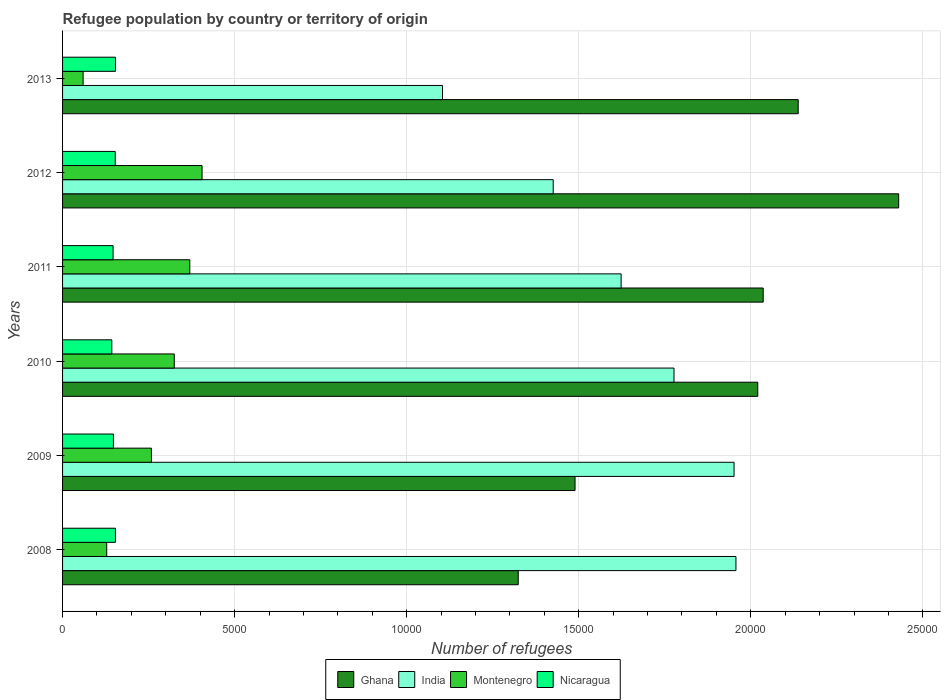How many groups of bars are there?
Offer a terse response. 6. Are the number of bars per tick equal to the number of legend labels?
Your answer should be very brief. Yes. How many bars are there on the 2nd tick from the bottom?
Make the answer very short. 4. In how many cases, is the number of bars for a given year not equal to the number of legend labels?
Offer a very short reply. 0. What is the number of refugees in Montenegro in 2008?
Keep it short and to the point. 1283. Across all years, what is the maximum number of refugees in Montenegro?
Provide a succinct answer. 4054. Across all years, what is the minimum number of refugees in Nicaragua?
Your response must be concise. 1431. In which year was the number of refugees in Montenegro maximum?
Provide a short and direct response. 2012. In which year was the number of refugees in Ghana minimum?
Ensure brevity in your answer.  2008. What is the total number of refugees in Ghana in the graph?
Offer a very short reply. 1.14e+05. What is the difference between the number of refugees in India in 2010 and that in 2011?
Keep it short and to the point. 1537. What is the difference between the number of refugees in Ghana in 2009 and the number of refugees in Nicaragua in 2012?
Offer a very short reply. 1.34e+04. What is the average number of refugees in Nicaragua per year?
Offer a very short reply. 1497.17. In the year 2009, what is the difference between the number of refugees in Ghana and number of refugees in Nicaragua?
Make the answer very short. 1.34e+04. In how many years, is the number of refugees in Ghana greater than 3000 ?
Your answer should be very brief. 6. What is the ratio of the number of refugees in Montenegro in 2012 to that in 2013?
Give a very brief answer. 6.79. What is the difference between the highest and the lowest number of refugees in Ghana?
Offer a terse response. 1.11e+04. In how many years, is the number of refugees in Montenegro greater than the average number of refugees in Montenegro taken over all years?
Provide a short and direct response. 4. Is it the case that in every year, the sum of the number of refugees in Nicaragua and number of refugees in Ghana is greater than the sum of number of refugees in India and number of refugees in Montenegro?
Your answer should be compact. Yes. What does the 2nd bar from the top in 2012 represents?
Your answer should be compact. Montenegro. What does the 4th bar from the bottom in 2011 represents?
Give a very brief answer. Nicaragua. How many years are there in the graph?
Ensure brevity in your answer.  6. What is the difference between two consecutive major ticks on the X-axis?
Offer a very short reply. 5000. Are the values on the major ticks of X-axis written in scientific E-notation?
Your response must be concise. No. Does the graph contain any zero values?
Offer a very short reply. No. How are the legend labels stacked?
Give a very brief answer. Horizontal. What is the title of the graph?
Your answer should be compact. Refugee population by country or territory of origin. Does "Cambodia" appear as one of the legend labels in the graph?
Offer a terse response. No. What is the label or title of the X-axis?
Provide a succinct answer. Number of refugees. What is the Number of refugees in Ghana in 2008?
Ensure brevity in your answer.  1.32e+04. What is the Number of refugees in India in 2008?
Ensure brevity in your answer.  1.96e+04. What is the Number of refugees in Montenegro in 2008?
Provide a short and direct response. 1283. What is the Number of refugees in Nicaragua in 2008?
Give a very brief answer. 1537. What is the Number of refugees in Ghana in 2009?
Offer a very short reply. 1.49e+04. What is the Number of refugees in India in 2009?
Make the answer very short. 1.95e+04. What is the Number of refugees of Montenegro in 2009?
Your answer should be very brief. 2582. What is the Number of refugees in Nicaragua in 2009?
Provide a succinct answer. 1478. What is the Number of refugees of Ghana in 2010?
Provide a short and direct response. 2.02e+04. What is the Number of refugees of India in 2010?
Ensure brevity in your answer.  1.78e+04. What is the Number of refugees of Montenegro in 2010?
Provide a succinct answer. 3246. What is the Number of refugees in Nicaragua in 2010?
Provide a succinct answer. 1431. What is the Number of refugees in Ghana in 2011?
Offer a terse response. 2.04e+04. What is the Number of refugees of India in 2011?
Your answer should be compact. 1.62e+04. What is the Number of refugees in Montenegro in 2011?
Provide a succinct answer. 3698. What is the Number of refugees in Nicaragua in 2011?
Offer a terse response. 1468. What is the Number of refugees in Ghana in 2012?
Offer a very short reply. 2.43e+04. What is the Number of refugees in India in 2012?
Provide a succinct answer. 1.43e+04. What is the Number of refugees of Montenegro in 2012?
Ensure brevity in your answer.  4054. What is the Number of refugees of Nicaragua in 2012?
Provide a short and direct response. 1531. What is the Number of refugees in Ghana in 2013?
Ensure brevity in your answer.  2.14e+04. What is the Number of refugees in India in 2013?
Give a very brief answer. 1.10e+04. What is the Number of refugees of Montenegro in 2013?
Provide a short and direct response. 597. What is the Number of refugees of Nicaragua in 2013?
Make the answer very short. 1538. Across all years, what is the maximum Number of refugees of Ghana?
Your answer should be compact. 2.43e+04. Across all years, what is the maximum Number of refugees in India?
Your answer should be compact. 1.96e+04. Across all years, what is the maximum Number of refugees of Montenegro?
Your answer should be very brief. 4054. Across all years, what is the maximum Number of refugees of Nicaragua?
Provide a short and direct response. 1538. Across all years, what is the minimum Number of refugees of Ghana?
Keep it short and to the point. 1.32e+04. Across all years, what is the minimum Number of refugees in India?
Your answer should be very brief. 1.10e+04. Across all years, what is the minimum Number of refugees of Montenegro?
Your answer should be very brief. 597. Across all years, what is the minimum Number of refugees in Nicaragua?
Provide a succinct answer. 1431. What is the total Number of refugees in Ghana in the graph?
Ensure brevity in your answer.  1.14e+05. What is the total Number of refugees in India in the graph?
Keep it short and to the point. 9.84e+04. What is the total Number of refugees of Montenegro in the graph?
Your response must be concise. 1.55e+04. What is the total Number of refugees of Nicaragua in the graph?
Keep it short and to the point. 8983. What is the difference between the Number of refugees of Ghana in 2008 and that in 2009?
Provide a short and direct response. -1651. What is the difference between the Number of refugees in India in 2008 and that in 2009?
Ensure brevity in your answer.  55. What is the difference between the Number of refugees of Montenegro in 2008 and that in 2009?
Provide a short and direct response. -1299. What is the difference between the Number of refugees of Ghana in 2008 and that in 2010?
Keep it short and to the point. -6961. What is the difference between the Number of refugees in India in 2008 and that in 2010?
Provide a short and direct response. 1800. What is the difference between the Number of refugees in Montenegro in 2008 and that in 2010?
Your answer should be compact. -1963. What is the difference between the Number of refugees in Nicaragua in 2008 and that in 2010?
Make the answer very short. 106. What is the difference between the Number of refugees in Ghana in 2008 and that in 2011?
Provide a short and direct response. -7119. What is the difference between the Number of refugees in India in 2008 and that in 2011?
Give a very brief answer. 3337. What is the difference between the Number of refugees in Montenegro in 2008 and that in 2011?
Your answer should be very brief. -2415. What is the difference between the Number of refugees in Nicaragua in 2008 and that in 2011?
Your answer should be compact. 69. What is the difference between the Number of refugees in Ghana in 2008 and that in 2012?
Ensure brevity in your answer.  -1.11e+04. What is the difference between the Number of refugees in India in 2008 and that in 2012?
Give a very brief answer. 5311. What is the difference between the Number of refugees in Montenegro in 2008 and that in 2012?
Ensure brevity in your answer.  -2771. What is the difference between the Number of refugees of Ghana in 2008 and that in 2013?
Your answer should be compact. -8136. What is the difference between the Number of refugees of India in 2008 and that in 2013?
Ensure brevity in your answer.  8527. What is the difference between the Number of refugees of Montenegro in 2008 and that in 2013?
Your response must be concise. 686. What is the difference between the Number of refugees of Ghana in 2009 and that in 2010?
Keep it short and to the point. -5310. What is the difference between the Number of refugees of India in 2009 and that in 2010?
Your answer should be compact. 1745. What is the difference between the Number of refugees in Montenegro in 2009 and that in 2010?
Offer a very short reply. -664. What is the difference between the Number of refugees in Nicaragua in 2009 and that in 2010?
Offer a terse response. 47. What is the difference between the Number of refugees in Ghana in 2009 and that in 2011?
Provide a short and direct response. -5468. What is the difference between the Number of refugees of India in 2009 and that in 2011?
Keep it short and to the point. 3282. What is the difference between the Number of refugees in Montenegro in 2009 and that in 2011?
Make the answer very short. -1116. What is the difference between the Number of refugees of Ghana in 2009 and that in 2012?
Offer a terse response. -9405. What is the difference between the Number of refugees in India in 2009 and that in 2012?
Your answer should be very brief. 5256. What is the difference between the Number of refugees of Montenegro in 2009 and that in 2012?
Provide a short and direct response. -1472. What is the difference between the Number of refugees of Nicaragua in 2009 and that in 2012?
Make the answer very short. -53. What is the difference between the Number of refugees in Ghana in 2009 and that in 2013?
Offer a very short reply. -6485. What is the difference between the Number of refugees in India in 2009 and that in 2013?
Your answer should be very brief. 8472. What is the difference between the Number of refugees in Montenegro in 2009 and that in 2013?
Your answer should be compact. 1985. What is the difference between the Number of refugees of Nicaragua in 2009 and that in 2013?
Give a very brief answer. -60. What is the difference between the Number of refugees in Ghana in 2010 and that in 2011?
Your response must be concise. -158. What is the difference between the Number of refugees of India in 2010 and that in 2011?
Your response must be concise. 1537. What is the difference between the Number of refugees of Montenegro in 2010 and that in 2011?
Give a very brief answer. -452. What is the difference between the Number of refugees of Nicaragua in 2010 and that in 2011?
Provide a succinct answer. -37. What is the difference between the Number of refugees of Ghana in 2010 and that in 2012?
Offer a terse response. -4095. What is the difference between the Number of refugees of India in 2010 and that in 2012?
Provide a succinct answer. 3511. What is the difference between the Number of refugees in Montenegro in 2010 and that in 2012?
Provide a short and direct response. -808. What is the difference between the Number of refugees of Nicaragua in 2010 and that in 2012?
Your answer should be very brief. -100. What is the difference between the Number of refugees in Ghana in 2010 and that in 2013?
Your response must be concise. -1175. What is the difference between the Number of refugees of India in 2010 and that in 2013?
Keep it short and to the point. 6727. What is the difference between the Number of refugees in Montenegro in 2010 and that in 2013?
Offer a very short reply. 2649. What is the difference between the Number of refugees in Nicaragua in 2010 and that in 2013?
Give a very brief answer. -107. What is the difference between the Number of refugees in Ghana in 2011 and that in 2012?
Make the answer very short. -3937. What is the difference between the Number of refugees in India in 2011 and that in 2012?
Your response must be concise. 1974. What is the difference between the Number of refugees in Montenegro in 2011 and that in 2012?
Give a very brief answer. -356. What is the difference between the Number of refugees of Nicaragua in 2011 and that in 2012?
Keep it short and to the point. -63. What is the difference between the Number of refugees of Ghana in 2011 and that in 2013?
Your answer should be compact. -1017. What is the difference between the Number of refugees of India in 2011 and that in 2013?
Ensure brevity in your answer.  5190. What is the difference between the Number of refugees in Montenegro in 2011 and that in 2013?
Make the answer very short. 3101. What is the difference between the Number of refugees in Nicaragua in 2011 and that in 2013?
Provide a succinct answer. -70. What is the difference between the Number of refugees of Ghana in 2012 and that in 2013?
Keep it short and to the point. 2920. What is the difference between the Number of refugees in India in 2012 and that in 2013?
Provide a short and direct response. 3216. What is the difference between the Number of refugees in Montenegro in 2012 and that in 2013?
Make the answer very short. 3457. What is the difference between the Number of refugees of Ghana in 2008 and the Number of refugees of India in 2009?
Provide a succinct answer. -6272. What is the difference between the Number of refugees in Ghana in 2008 and the Number of refugees in Montenegro in 2009?
Offer a very short reply. 1.07e+04. What is the difference between the Number of refugees in Ghana in 2008 and the Number of refugees in Nicaragua in 2009?
Offer a very short reply. 1.18e+04. What is the difference between the Number of refugees of India in 2008 and the Number of refugees of Montenegro in 2009?
Offer a very short reply. 1.70e+04. What is the difference between the Number of refugees of India in 2008 and the Number of refugees of Nicaragua in 2009?
Make the answer very short. 1.81e+04. What is the difference between the Number of refugees in Montenegro in 2008 and the Number of refugees in Nicaragua in 2009?
Provide a short and direct response. -195. What is the difference between the Number of refugees of Ghana in 2008 and the Number of refugees of India in 2010?
Keep it short and to the point. -4527. What is the difference between the Number of refugees of Ghana in 2008 and the Number of refugees of Montenegro in 2010?
Make the answer very short. 9996. What is the difference between the Number of refugees in Ghana in 2008 and the Number of refugees in Nicaragua in 2010?
Offer a terse response. 1.18e+04. What is the difference between the Number of refugees of India in 2008 and the Number of refugees of Montenegro in 2010?
Keep it short and to the point. 1.63e+04. What is the difference between the Number of refugees in India in 2008 and the Number of refugees in Nicaragua in 2010?
Keep it short and to the point. 1.81e+04. What is the difference between the Number of refugees in Montenegro in 2008 and the Number of refugees in Nicaragua in 2010?
Your answer should be very brief. -148. What is the difference between the Number of refugees in Ghana in 2008 and the Number of refugees in India in 2011?
Provide a succinct answer. -2990. What is the difference between the Number of refugees of Ghana in 2008 and the Number of refugees of Montenegro in 2011?
Your response must be concise. 9544. What is the difference between the Number of refugees of Ghana in 2008 and the Number of refugees of Nicaragua in 2011?
Provide a short and direct response. 1.18e+04. What is the difference between the Number of refugees in India in 2008 and the Number of refugees in Montenegro in 2011?
Keep it short and to the point. 1.59e+04. What is the difference between the Number of refugees of India in 2008 and the Number of refugees of Nicaragua in 2011?
Offer a very short reply. 1.81e+04. What is the difference between the Number of refugees in Montenegro in 2008 and the Number of refugees in Nicaragua in 2011?
Give a very brief answer. -185. What is the difference between the Number of refugees of Ghana in 2008 and the Number of refugees of India in 2012?
Give a very brief answer. -1016. What is the difference between the Number of refugees of Ghana in 2008 and the Number of refugees of Montenegro in 2012?
Provide a short and direct response. 9188. What is the difference between the Number of refugees of Ghana in 2008 and the Number of refugees of Nicaragua in 2012?
Provide a short and direct response. 1.17e+04. What is the difference between the Number of refugees in India in 2008 and the Number of refugees in Montenegro in 2012?
Ensure brevity in your answer.  1.55e+04. What is the difference between the Number of refugees in India in 2008 and the Number of refugees in Nicaragua in 2012?
Make the answer very short. 1.80e+04. What is the difference between the Number of refugees of Montenegro in 2008 and the Number of refugees of Nicaragua in 2012?
Ensure brevity in your answer.  -248. What is the difference between the Number of refugees in Ghana in 2008 and the Number of refugees in India in 2013?
Your answer should be very brief. 2200. What is the difference between the Number of refugees in Ghana in 2008 and the Number of refugees in Montenegro in 2013?
Provide a short and direct response. 1.26e+04. What is the difference between the Number of refugees in Ghana in 2008 and the Number of refugees in Nicaragua in 2013?
Your answer should be very brief. 1.17e+04. What is the difference between the Number of refugees of India in 2008 and the Number of refugees of Montenegro in 2013?
Provide a short and direct response. 1.90e+04. What is the difference between the Number of refugees in India in 2008 and the Number of refugees in Nicaragua in 2013?
Your answer should be very brief. 1.80e+04. What is the difference between the Number of refugees in Montenegro in 2008 and the Number of refugees in Nicaragua in 2013?
Offer a very short reply. -255. What is the difference between the Number of refugees in Ghana in 2009 and the Number of refugees in India in 2010?
Offer a terse response. -2876. What is the difference between the Number of refugees in Ghana in 2009 and the Number of refugees in Montenegro in 2010?
Provide a succinct answer. 1.16e+04. What is the difference between the Number of refugees in Ghana in 2009 and the Number of refugees in Nicaragua in 2010?
Ensure brevity in your answer.  1.35e+04. What is the difference between the Number of refugees in India in 2009 and the Number of refugees in Montenegro in 2010?
Offer a terse response. 1.63e+04. What is the difference between the Number of refugees of India in 2009 and the Number of refugees of Nicaragua in 2010?
Give a very brief answer. 1.81e+04. What is the difference between the Number of refugees in Montenegro in 2009 and the Number of refugees in Nicaragua in 2010?
Your response must be concise. 1151. What is the difference between the Number of refugees in Ghana in 2009 and the Number of refugees in India in 2011?
Offer a terse response. -1339. What is the difference between the Number of refugees of Ghana in 2009 and the Number of refugees of Montenegro in 2011?
Provide a short and direct response. 1.12e+04. What is the difference between the Number of refugees in Ghana in 2009 and the Number of refugees in Nicaragua in 2011?
Offer a very short reply. 1.34e+04. What is the difference between the Number of refugees of India in 2009 and the Number of refugees of Montenegro in 2011?
Your answer should be compact. 1.58e+04. What is the difference between the Number of refugees in India in 2009 and the Number of refugees in Nicaragua in 2011?
Your response must be concise. 1.80e+04. What is the difference between the Number of refugees in Montenegro in 2009 and the Number of refugees in Nicaragua in 2011?
Provide a succinct answer. 1114. What is the difference between the Number of refugees of Ghana in 2009 and the Number of refugees of India in 2012?
Offer a very short reply. 635. What is the difference between the Number of refugees in Ghana in 2009 and the Number of refugees in Montenegro in 2012?
Provide a short and direct response. 1.08e+04. What is the difference between the Number of refugees of Ghana in 2009 and the Number of refugees of Nicaragua in 2012?
Offer a terse response. 1.34e+04. What is the difference between the Number of refugees of India in 2009 and the Number of refugees of Montenegro in 2012?
Your answer should be very brief. 1.55e+04. What is the difference between the Number of refugees in India in 2009 and the Number of refugees in Nicaragua in 2012?
Offer a terse response. 1.80e+04. What is the difference between the Number of refugees of Montenegro in 2009 and the Number of refugees of Nicaragua in 2012?
Your answer should be compact. 1051. What is the difference between the Number of refugees of Ghana in 2009 and the Number of refugees of India in 2013?
Your response must be concise. 3851. What is the difference between the Number of refugees of Ghana in 2009 and the Number of refugees of Montenegro in 2013?
Your response must be concise. 1.43e+04. What is the difference between the Number of refugees in Ghana in 2009 and the Number of refugees in Nicaragua in 2013?
Give a very brief answer. 1.34e+04. What is the difference between the Number of refugees of India in 2009 and the Number of refugees of Montenegro in 2013?
Ensure brevity in your answer.  1.89e+04. What is the difference between the Number of refugees of India in 2009 and the Number of refugees of Nicaragua in 2013?
Your answer should be compact. 1.80e+04. What is the difference between the Number of refugees in Montenegro in 2009 and the Number of refugees in Nicaragua in 2013?
Your answer should be very brief. 1044. What is the difference between the Number of refugees of Ghana in 2010 and the Number of refugees of India in 2011?
Offer a terse response. 3971. What is the difference between the Number of refugees in Ghana in 2010 and the Number of refugees in Montenegro in 2011?
Give a very brief answer. 1.65e+04. What is the difference between the Number of refugees of Ghana in 2010 and the Number of refugees of Nicaragua in 2011?
Offer a terse response. 1.87e+04. What is the difference between the Number of refugees in India in 2010 and the Number of refugees in Montenegro in 2011?
Your answer should be compact. 1.41e+04. What is the difference between the Number of refugees in India in 2010 and the Number of refugees in Nicaragua in 2011?
Keep it short and to the point. 1.63e+04. What is the difference between the Number of refugees in Montenegro in 2010 and the Number of refugees in Nicaragua in 2011?
Ensure brevity in your answer.  1778. What is the difference between the Number of refugees of Ghana in 2010 and the Number of refugees of India in 2012?
Provide a succinct answer. 5945. What is the difference between the Number of refugees of Ghana in 2010 and the Number of refugees of Montenegro in 2012?
Your answer should be very brief. 1.61e+04. What is the difference between the Number of refugees in Ghana in 2010 and the Number of refugees in Nicaragua in 2012?
Your answer should be very brief. 1.87e+04. What is the difference between the Number of refugees of India in 2010 and the Number of refugees of Montenegro in 2012?
Provide a short and direct response. 1.37e+04. What is the difference between the Number of refugees of India in 2010 and the Number of refugees of Nicaragua in 2012?
Your response must be concise. 1.62e+04. What is the difference between the Number of refugees in Montenegro in 2010 and the Number of refugees in Nicaragua in 2012?
Give a very brief answer. 1715. What is the difference between the Number of refugees of Ghana in 2010 and the Number of refugees of India in 2013?
Your answer should be compact. 9161. What is the difference between the Number of refugees of Ghana in 2010 and the Number of refugees of Montenegro in 2013?
Keep it short and to the point. 1.96e+04. What is the difference between the Number of refugees of Ghana in 2010 and the Number of refugees of Nicaragua in 2013?
Offer a terse response. 1.87e+04. What is the difference between the Number of refugees of India in 2010 and the Number of refugees of Montenegro in 2013?
Make the answer very short. 1.72e+04. What is the difference between the Number of refugees of India in 2010 and the Number of refugees of Nicaragua in 2013?
Give a very brief answer. 1.62e+04. What is the difference between the Number of refugees of Montenegro in 2010 and the Number of refugees of Nicaragua in 2013?
Provide a short and direct response. 1708. What is the difference between the Number of refugees of Ghana in 2011 and the Number of refugees of India in 2012?
Make the answer very short. 6103. What is the difference between the Number of refugees of Ghana in 2011 and the Number of refugees of Montenegro in 2012?
Offer a very short reply. 1.63e+04. What is the difference between the Number of refugees of Ghana in 2011 and the Number of refugees of Nicaragua in 2012?
Give a very brief answer. 1.88e+04. What is the difference between the Number of refugees of India in 2011 and the Number of refugees of Montenegro in 2012?
Your answer should be very brief. 1.22e+04. What is the difference between the Number of refugees of India in 2011 and the Number of refugees of Nicaragua in 2012?
Keep it short and to the point. 1.47e+04. What is the difference between the Number of refugees of Montenegro in 2011 and the Number of refugees of Nicaragua in 2012?
Make the answer very short. 2167. What is the difference between the Number of refugees in Ghana in 2011 and the Number of refugees in India in 2013?
Make the answer very short. 9319. What is the difference between the Number of refugees in Ghana in 2011 and the Number of refugees in Montenegro in 2013?
Your answer should be compact. 1.98e+04. What is the difference between the Number of refugees in Ghana in 2011 and the Number of refugees in Nicaragua in 2013?
Offer a very short reply. 1.88e+04. What is the difference between the Number of refugees in India in 2011 and the Number of refugees in Montenegro in 2013?
Offer a terse response. 1.56e+04. What is the difference between the Number of refugees of India in 2011 and the Number of refugees of Nicaragua in 2013?
Offer a terse response. 1.47e+04. What is the difference between the Number of refugees of Montenegro in 2011 and the Number of refugees of Nicaragua in 2013?
Your response must be concise. 2160. What is the difference between the Number of refugees of Ghana in 2012 and the Number of refugees of India in 2013?
Provide a short and direct response. 1.33e+04. What is the difference between the Number of refugees of Ghana in 2012 and the Number of refugees of Montenegro in 2013?
Provide a succinct answer. 2.37e+04. What is the difference between the Number of refugees in Ghana in 2012 and the Number of refugees in Nicaragua in 2013?
Offer a terse response. 2.28e+04. What is the difference between the Number of refugees of India in 2012 and the Number of refugees of Montenegro in 2013?
Offer a very short reply. 1.37e+04. What is the difference between the Number of refugees in India in 2012 and the Number of refugees in Nicaragua in 2013?
Make the answer very short. 1.27e+04. What is the difference between the Number of refugees of Montenegro in 2012 and the Number of refugees of Nicaragua in 2013?
Your answer should be very brief. 2516. What is the average Number of refugees in Ghana per year?
Provide a succinct answer. 1.91e+04. What is the average Number of refugees of India per year?
Ensure brevity in your answer.  1.64e+04. What is the average Number of refugees of Montenegro per year?
Provide a short and direct response. 2576.67. What is the average Number of refugees in Nicaragua per year?
Keep it short and to the point. 1497.17. In the year 2008, what is the difference between the Number of refugees in Ghana and Number of refugees in India?
Give a very brief answer. -6327. In the year 2008, what is the difference between the Number of refugees in Ghana and Number of refugees in Montenegro?
Ensure brevity in your answer.  1.20e+04. In the year 2008, what is the difference between the Number of refugees in Ghana and Number of refugees in Nicaragua?
Your answer should be very brief. 1.17e+04. In the year 2008, what is the difference between the Number of refugees of India and Number of refugees of Montenegro?
Offer a terse response. 1.83e+04. In the year 2008, what is the difference between the Number of refugees of India and Number of refugees of Nicaragua?
Offer a terse response. 1.80e+04. In the year 2008, what is the difference between the Number of refugees of Montenegro and Number of refugees of Nicaragua?
Provide a short and direct response. -254. In the year 2009, what is the difference between the Number of refugees of Ghana and Number of refugees of India?
Provide a succinct answer. -4621. In the year 2009, what is the difference between the Number of refugees in Ghana and Number of refugees in Montenegro?
Provide a succinct answer. 1.23e+04. In the year 2009, what is the difference between the Number of refugees in Ghana and Number of refugees in Nicaragua?
Your response must be concise. 1.34e+04. In the year 2009, what is the difference between the Number of refugees in India and Number of refugees in Montenegro?
Offer a very short reply. 1.69e+04. In the year 2009, what is the difference between the Number of refugees in India and Number of refugees in Nicaragua?
Provide a short and direct response. 1.80e+04. In the year 2009, what is the difference between the Number of refugees in Montenegro and Number of refugees in Nicaragua?
Provide a short and direct response. 1104. In the year 2010, what is the difference between the Number of refugees in Ghana and Number of refugees in India?
Offer a very short reply. 2434. In the year 2010, what is the difference between the Number of refugees in Ghana and Number of refugees in Montenegro?
Your answer should be compact. 1.70e+04. In the year 2010, what is the difference between the Number of refugees in Ghana and Number of refugees in Nicaragua?
Ensure brevity in your answer.  1.88e+04. In the year 2010, what is the difference between the Number of refugees in India and Number of refugees in Montenegro?
Your answer should be compact. 1.45e+04. In the year 2010, what is the difference between the Number of refugees of India and Number of refugees of Nicaragua?
Ensure brevity in your answer.  1.63e+04. In the year 2010, what is the difference between the Number of refugees in Montenegro and Number of refugees in Nicaragua?
Your response must be concise. 1815. In the year 2011, what is the difference between the Number of refugees of Ghana and Number of refugees of India?
Your answer should be very brief. 4129. In the year 2011, what is the difference between the Number of refugees of Ghana and Number of refugees of Montenegro?
Your answer should be compact. 1.67e+04. In the year 2011, what is the difference between the Number of refugees in Ghana and Number of refugees in Nicaragua?
Offer a terse response. 1.89e+04. In the year 2011, what is the difference between the Number of refugees of India and Number of refugees of Montenegro?
Your response must be concise. 1.25e+04. In the year 2011, what is the difference between the Number of refugees in India and Number of refugees in Nicaragua?
Provide a succinct answer. 1.48e+04. In the year 2011, what is the difference between the Number of refugees in Montenegro and Number of refugees in Nicaragua?
Make the answer very short. 2230. In the year 2012, what is the difference between the Number of refugees of Ghana and Number of refugees of India?
Provide a succinct answer. 1.00e+04. In the year 2012, what is the difference between the Number of refugees in Ghana and Number of refugees in Montenegro?
Keep it short and to the point. 2.02e+04. In the year 2012, what is the difference between the Number of refugees of Ghana and Number of refugees of Nicaragua?
Your response must be concise. 2.28e+04. In the year 2012, what is the difference between the Number of refugees of India and Number of refugees of Montenegro?
Your answer should be very brief. 1.02e+04. In the year 2012, what is the difference between the Number of refugees of India and Number of refugees of Nicaragua?
Ensure brevity in your answer.  1.27e+04. In the year 2012, what is the difference between the Number of refugees in Montenegro and Number of refugees in Nicaragua?
Ensure brevity in your answer.  2523. In the year 2013, what is the difference between the Number of refugees of Ghana and Number of refugees of India?
Keep it short and to the point. 1.03e+04. In the year 2013, what is the difference between the Number of refugees in Ghana and Number of refugees in Montenegro?
Keep it short and to the point. 2.08e+04. In the year 2013, what is the difference between the Number of refugees of Ghana and Number of refugees of Nicaragua?
Your answer should be very brief. 1.98e+04. In the year 2013, what is the difference between the Number of refugees of India and Number of refugees of Montenegro?
Provide a short and direct response. 1.04e+04. In the year 2013, what is the difference between the Number of refugees of India and Number of refugees of Nicaragua?
Your response must be concise. 9504. In the year 2013, what is the difference between the Number of refugees in Montenegro and Number of refugees in Nicaragua?
Make the answer very short. -941. What is the ratio of the Number of refugees in Ghana in 2008 to that in 2009?
Your response must be concise. 0.89. What is the ratio of the Number of refugees in Montenegro in 2008 to that in 2009?
Give a very brief answer. 0.5. What is the ratio of the Number of refugees of Nicaragua in 2008 to that in 2009?
Provide a succinct answer. 1.04. What is the ratio of the Number of refugees of Ghana in 2008 to that in 2010?
Your answer should be very brief. 0.66. What is the ratio of the Number of refugees of India in 2008 to that in 2010?
Your answer should be compact. 1.1. What is the ratio of the Number of refugees of Montenegro in 2008 to that in 2010?
Your answer should be very brief. 0.4. What is the ratio of the Number of refugees of Nicaragua in 2008 to that in 2010?
Give a very brief answer. 1.07. What is the ratio of the Number of refugees of Ghana in 2008 to that in 2011?
Ensure brevity in your answer.  0.65. What is the ratio of the Number of refugees in India in 2008 to that in 2011?
Ensure brevity in your answer.  1.21. What is the ratio of the Number of refugees in Montenegro in 2008 to that in 2011?
Offer a very short reply. 0.35. What is the ratio of the Number of refugees of Nicaragua in 2008 to that in 2011?
Provide a succinct answer. 1.05. What is the ratio of the Number of refugees in Ghana in 2008 to that in 2012?
Your response must be concise. 0.55. What is the ratio of the Number of refugees in India in 2008 to that in 2012?
Make the answer very short. 1.37. What is the ratio of the Number of refugees of Montenegro in 2008 to that in 2012?
Give a very brief answer. 0.32. What is the ratio of the Number of refugees in Ghana in 2008 to that in 2013?
Make the answer very short. 0.62. What is the ratio of the Number of refugees of India in 2008 to that in 2013?
Provide a succinct answer. 1.77. What is the ratio of the Number of refugees of Montenegro in 2008 to that in 2013?
Offer a very short reply. 2.15. What is the ratio of the Number of refugees of Ghana in 2009 to that in 2010?
Your response must be concise. 0.74. What is the ratio of the Number of refugees of India in 2009 to that in 2010?
Give a very brief answer. 1.1. What is the ratio of the Number of refugees in Montenegro in 2009 to that in 2010?
Your answer should be very brief. 0.8. What is the ratio of the Number of refugees in Nicaragua in 2009 to that in 2010?
Provide a short and direct response. 1.03. What is the ratio of the Number of refugees of Ghana in 2009 to that in 2011?
Your response must be concise. 0.73. What is the ratio of the Number of refugees in India in 2009 to that in 2011?
Offer a very short reply. 1.2. What is the ratio of the Number of refugees in Montenegro in 2009 to that in 2011?
Your response must be concise. 0.7. What is the ratio of the Number of refugees in Nicaragua in 2009 to that in 2011?
Your response must be concise. 1.01. What is the ratio of the Number of refugees in Ghana in 2009 to that in 2012?
Provide a short and direct response. 0.61. What is the ratio of the Number of refugees of India in 2009 to that in 2012?
Provide a succinct answer. 1.37. What is the ratio of the Number of refugees of Montenegro in 2009 to that in 2012?
Provide a succinct answer. 0.64. What is the ratio of the Number of refugees in Nicaragua in 2009 to that in 2012?
Your answer should be very brief. 0.97. What is the ratio of the Number of refugees in Ghana in 2009 to that in 2013?
Make the answer very short. 0.7. What is the ratio of the Number of refugees in India in 2009 to that in 2013?
Your response must be concise. 1.77. What is the ratio of the Number of refugees of Montenegro in 2009 to that in 2013?
Your answer should be compact. 4.33. What is the ratio of the Number of refugees in Ghana in 2010 to that in 2011?
Your response must be concise. 0.99. What is the ratio of the Number of refugees of India in 2010 to that in 2011?
Provide a succinct answer. 1.09. What is the ratio of the Number of refugees in Montenegro in 2010 to that in 2011?
Offer a very short reply. 0.88. What is the ratio of the Number of refugees of Nicaragua in 2010 to that in 2011?
Offer a very short reply. 0.97. What is the ratio of the Number of refugees in Ghana in 2010 to that in 2012?
Keep it short and to the point. 0.83. What is the ratio of the Number of refugees of India in 2010 to that in 2012?
Give a very brief answer. 1.25. What is the ratio of the Number of refugees in Montenegro in 2010 to that in 2012?
Your answer should be very brief. 0.8. What is the ratio of the Number of refugees in Nicaragua in 2010 to that in 2012?
Your answer should be very brief. 0.93. What is the ratio of the Number of refugees of Ghana in 2010 to that in 2013?
Offer a terse response. 0.94. What is the ratio of the Number of refugees of India in 2010 to that in 2013?
Make the answer very short. 1.61. What is the ratio of the Number of refugees of Montenegro in 2010 to that in 2013?
Make the answer very short. 5.44. What is the ratio of the Number of refugees in Nicaragua in 2010 to that in 2013?
Your answer should be very brief. 0.93. What is the ratio of the Number of refugees in Ghana in 2011 to that in 2012?
Provide a short and direct response. 0.84. What is the ratio of the Number of refugees of India in 2011 to that in 2012?
Ensure brevity in your answer.  1.14. What is the ratio of the Number of refugees in Montenegro in 2011 to that in 2012?
Your answer should be compact. 0.91. What is the ratio of the Number of refugees in Nicaragua in 2011 to that in 2012?
Your response must be concise. 0.96. What is the ratio of the Number of refugees in India in 2011 to that in 2013?
Your response must be concise. 1.47. What is the ratio of the Number of refugees in Montenegro in 2011 to that in 2013?
Give a very brief answer. 6.19. What is the ratio of the Number of refugees of Nicaragua in 2011 to that in 2013?
Give a very brief answer. 0.95. What is the ratio of the Number of refugees of Ghana in 2012 to that in 2013?
Provide a succinct answer. 1.14. What is the ratio of the Number of refugees of India in 2012 to that in 2013?
Your answer should be compact. 1.29. What is the ratio of the Number of refugees in Montenegro in 2012 to that in 2013?
Provide a succinct answer. 6.79. What is the ratio of the Number of refugees of Nicaragua in 2012 to that in 2013?
Your answer should be compact. 1. What is the difference between the highest and the second highest Number of refugees of Ghana?
Offer a terse response. 2920. What is the difference between the highest and the second highest Number of refugees of India?
Make the answer very short. 55. What is the difference between the highest and the second highest Number of refugees of Montenegro?
Your answer should be very brief. 356. What is the difference between the highest and the second highest Number of refugees of Nicaragua?
Your response must be concise. 1. What is the difference between the highest and the lowest Number of refugees of Ghana?
Provide a short and direct response. 1.11e+04. What is the difference between the highest and the lowest Number of refugees of India?
Provide a succinct answer. 8527. What is the difference between the highest and the lowest Number of refugees in Montenegro?
Your answer should be compact. 3457. What is the difference between the highest and the lowest Number of refugees of Nicaragua?
Provide a short and direct response. 107. 